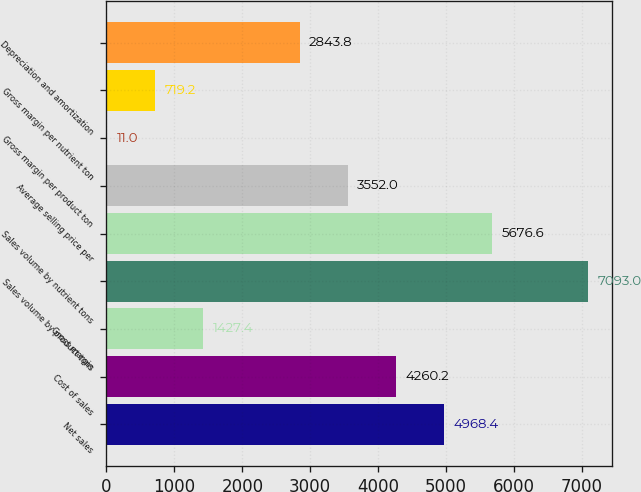Convert chart to OTSL. <chart><loc_0><loc_0><loc_500><loc_500><bar_chart><fcel>Net sales<fcel>Cost of sales<fcel>Gross margin<fcel>Sales volume by product tons<fcel>Sales volume by nutrient tons<fcel>Average selling price per<fcel>Gross margin per product ton<fcel>Gross margin per nutrient ton<fcel>Depreciation and amortization<nl><fcel>4968.4<fcel>4260.2<fcel>1427.4<fcel>7093<fcel>5676.6<fcel>3552<fcel>11<fcel>719.2<fcel>2843.8<nl></chart> 